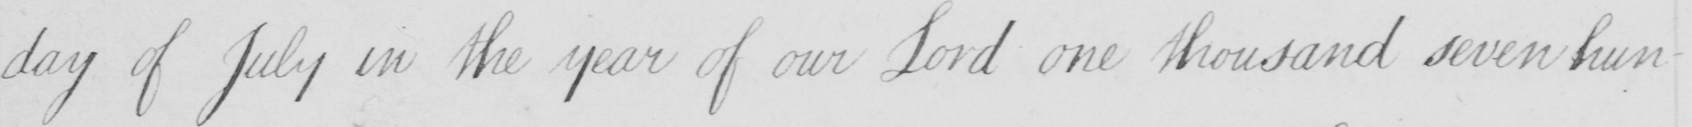What is written in this line of handwriting? day of July in the year of our Lord one thousand seven hun- 